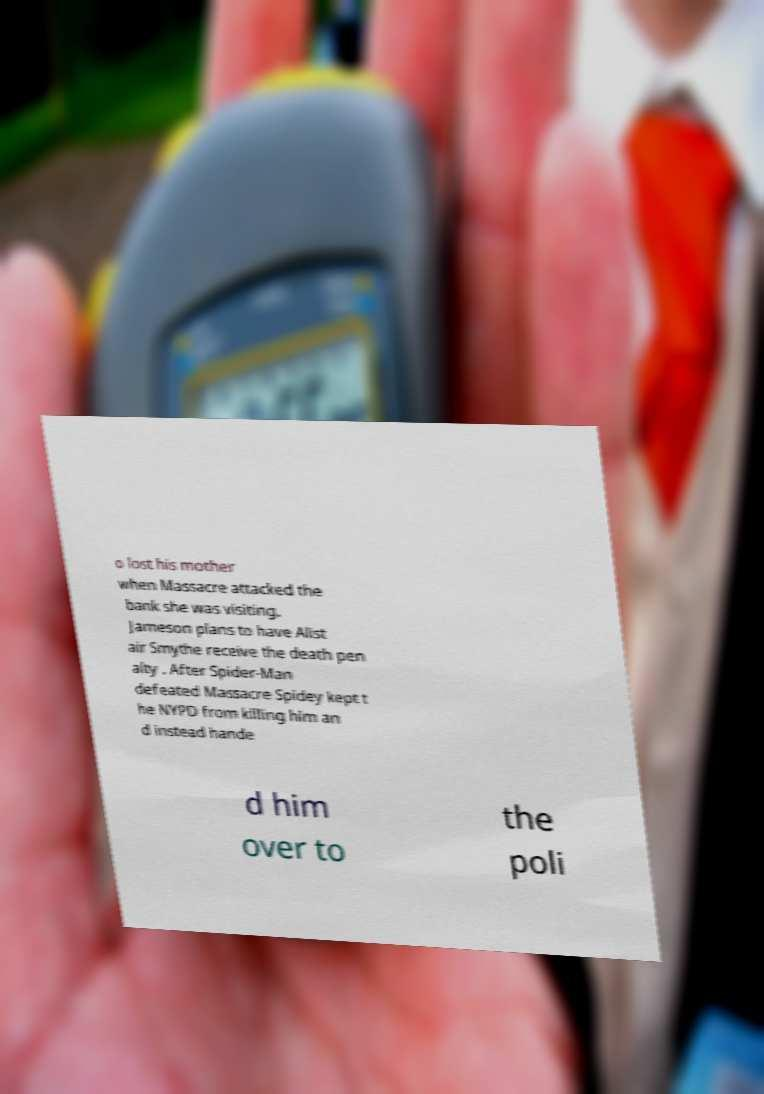I need the written content from this picture converted into text. Can you do that? o lost his mother when Massacre attacked the bank she was visiting. Jameson plans to have Alist air Smythe receive the death pen alty . After Spider-Man defeated Massacre Spidey kept t he NYPD from killing him an d instead hande d him over to the poli 